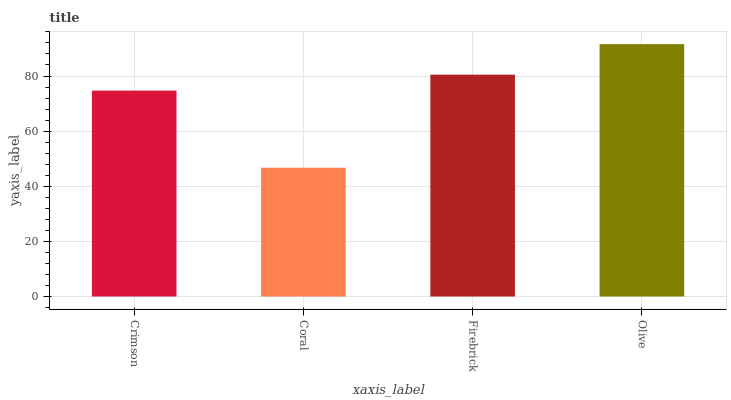Is Coral the minimum?
Answer yes or no. Yes. Is Olive the maximum?
Answer yes or no. Yes. Is Firebrick the minimum?
Answer yes or no. No. Is Firebrick the maximum?
Answer yes or no. No. Is Firebrick greater than Coral?
Answer yes or no. Yes. Is Coral less than Firebrick?
Answer yes or no. Yes. Is Coral greater than Firebrick?
Answer yes or no. No. Is Firebrick less than Coral?
Answer yes or no. No. Is Firebrick the high median?
Answer yes or no. Yes. Is Crimson the low median?
Answer yes or no. Yes. Is Olive the high median?
Answer yes or no. No. Is Firebrick the low median?
Answer yes or no. No. 